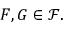Convert formula to latex. <formula><loc_0><loc_0><loc_500><loc_500>F , G \in { \mathcal { F } } .</formula> 